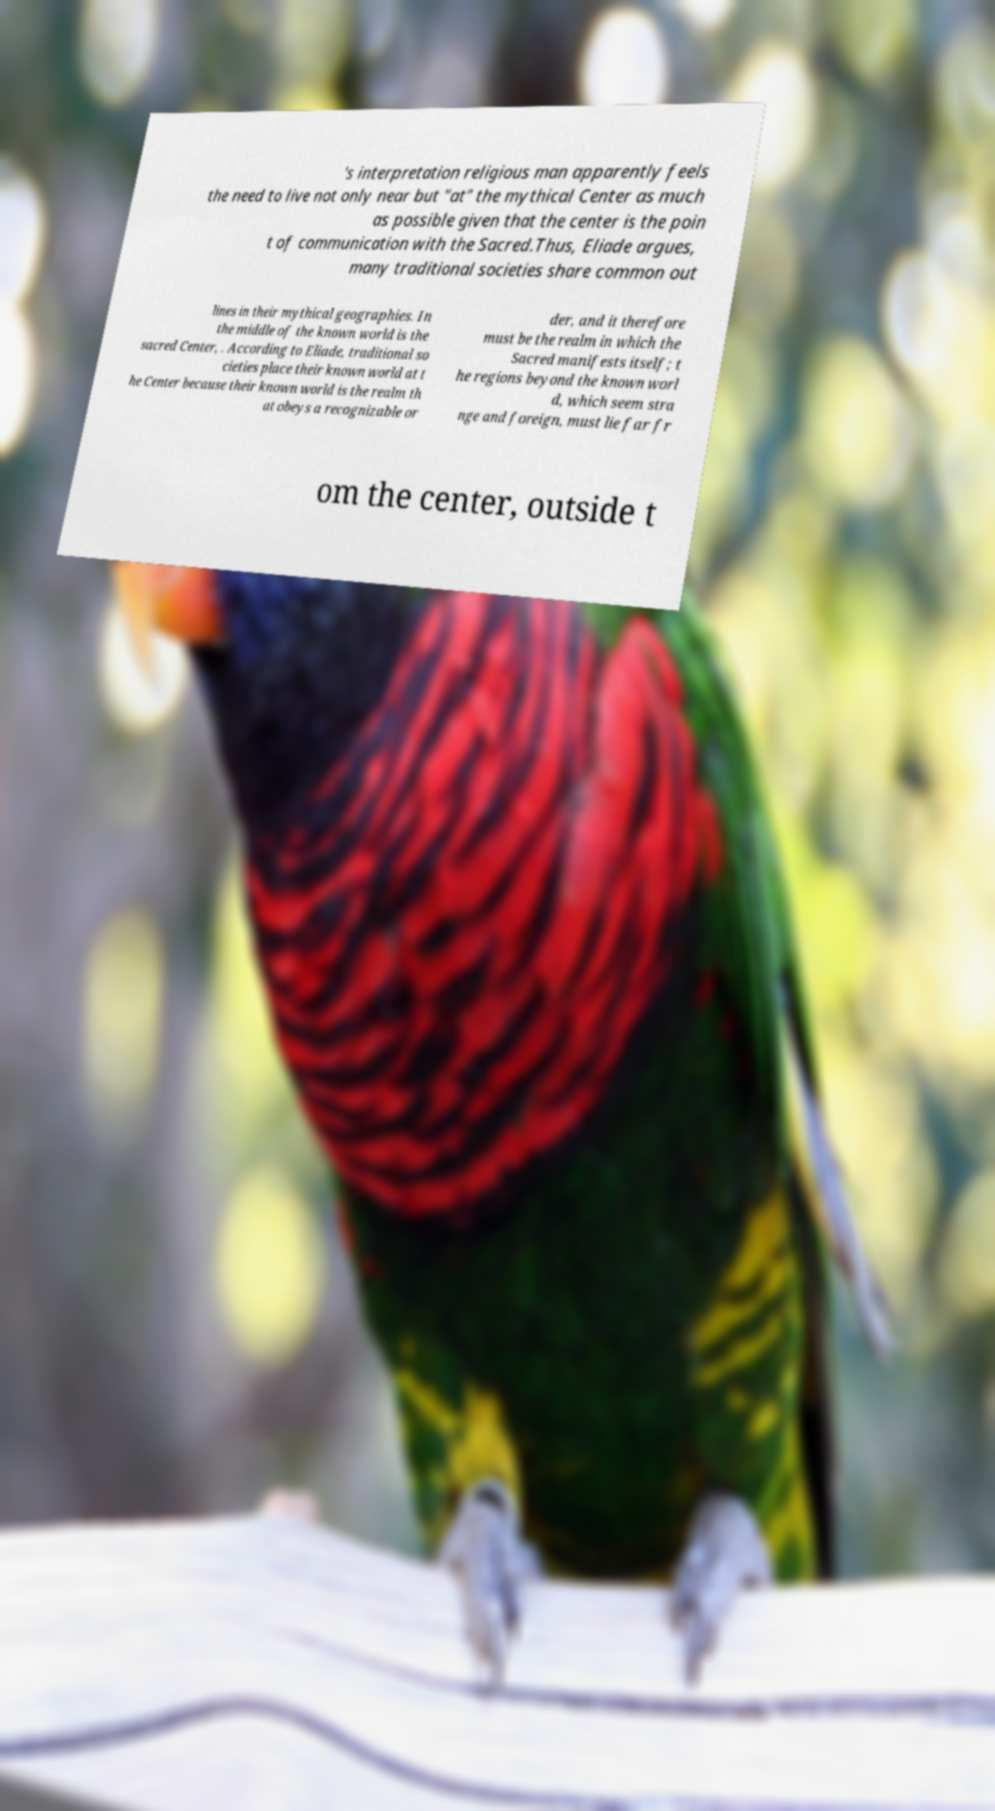Please identify and transcribe the text found in this image. 's interpretation religious man apparently feels the need to live not only near but "at" the mythical Center as much as possible given that the center is the poin t of communication with the Sacred.Thus, Eliade argues, many traditional societies share common out lines in their mythical geographies. In the middle of the known world is the sacred Center, . According to Eliade, traditional so cieties place their known world at t he Center because their known world is the realm th at obeys a recognizable or der, and it therefore must be the realm in which the Sacred manifests itself; t he regions beyond the known worl d, which seem stra nge and foreign, must lie far fr om the center, outside t 